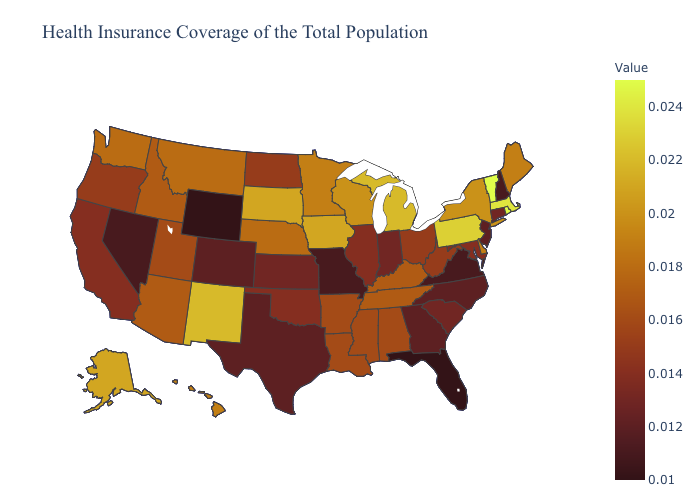Among the states that border Arizona , which have the highest value?
Quick response, please. New Mexico. Does Michigan have the highest value in the MidWest?
Concise answer only. Yes. Does Wisconsin have the lowest value in the USA?
Answer briefly. No. Does New York have the lowest value in the USA?
Write a very short answer. No. Which states have the lowest value in the USA?
Give a very brief answer. Florida, Wyoming. 